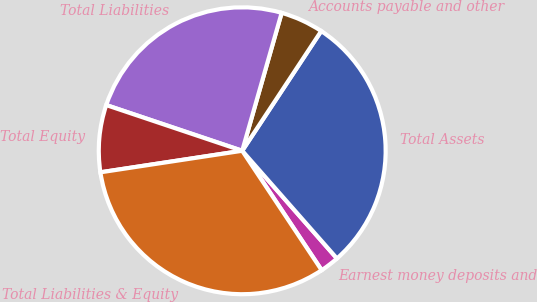<chart> <loc_0><loc_0><loc_500><loc_500><pie_chart><fcel>Earnest money deposits and<fcel>Total Assets<fcel>Accounts payable and other<fcel>Total Liabilities<fcel>Total Equity<fcel>Total Liabilities & Equity<nl><fcel>2.14%<fcel>29.23%<fcel>4.85%<fcel>24.27%<fcel>7.56%<fcel>31.94%<nl></chart> 